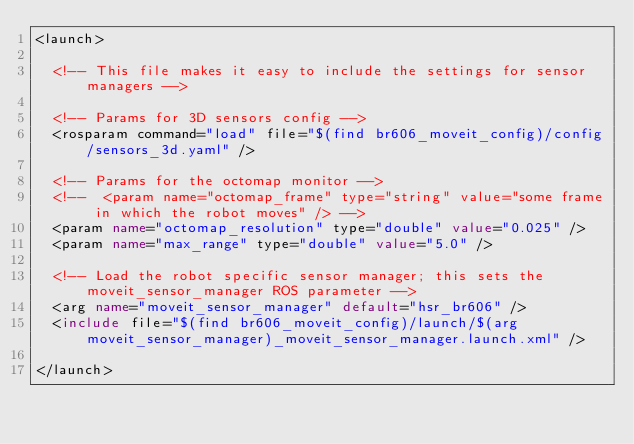<code> <loc_0><loc_0><loc_500><loc_500><_XML_><launch>

  <!-- This file makes it easy to include the settings for sensor managers -->

  <!-- Params for 3D sensors config -->
  <rosparam command="load" file="$(find br606_moveit_config)/config/sensors_3d.yaml" />

  <!-- Params for the octomap monitor -->
  <!--  <param name="octomap_frame" type="string" value="some frame in which the robot moves" /> -->
  <param name="octomap_resolution" type="double" value="0.025" />
  <param name="max_range" type="double" value="5.0" />

  <!-- Load the robot specific sensor manager; this sets the moveit_sensor_manager ROS parameter -->
  <arg name="moveit_sensor_manager" default="hsr_br606" />
  <include file="$(find br606_moveit_config)/launch/$(arg moveit_sensor_manager)_moveit_sensor_manager.launch.xml" />

</launch>
</code> 